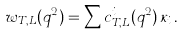<formula> <loc_0><loc_0><loc_500><loc_500>w _ { T , L } ( q ^ { 2 } ) = \sum c ^ { i } _ { T , L } ( q ^ { 2 } ) \, \kappa _ { i } \, .</formula> 